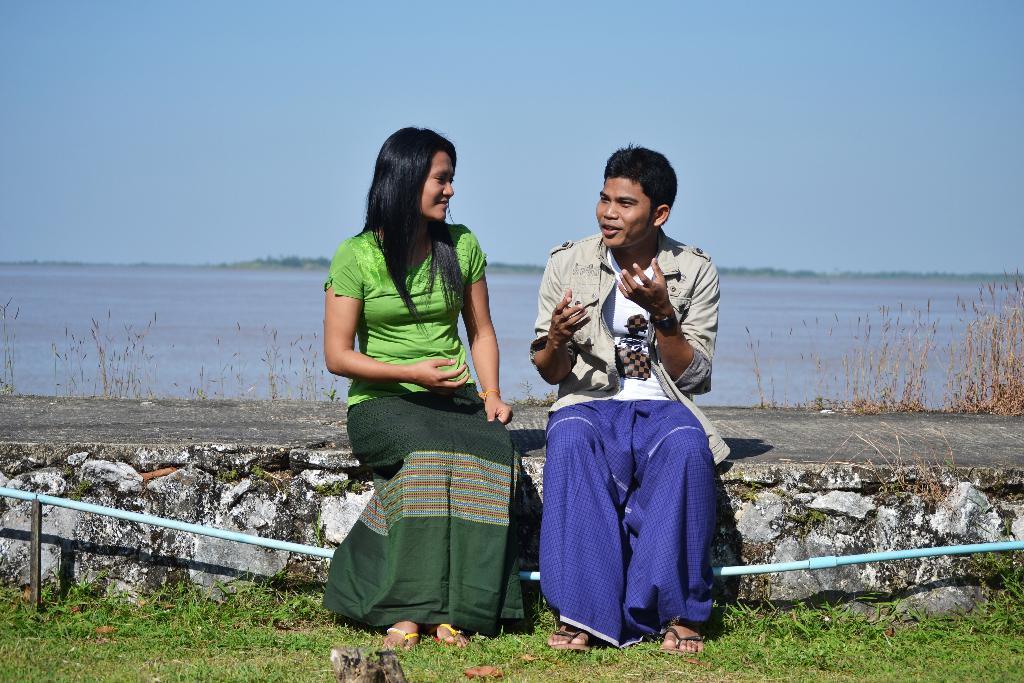How would you summarize this image in a sentence or two? There is one woman and a man is sitting on a platform as we can see in the middle of this image. We can see the water surface in the background and the sky is at the top of this image. We can see a grassy land at the bottom of this image. 